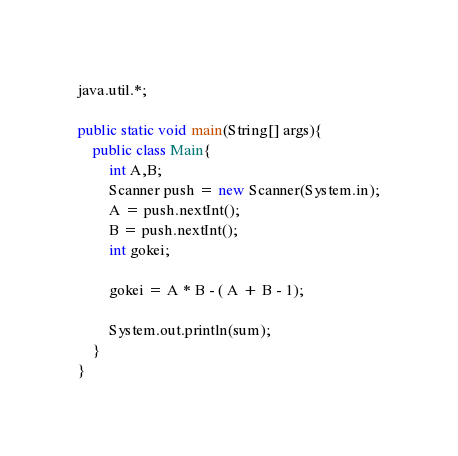<code> <loc_0><loc_0><loc_500><loc_500><_Java_>java.util.*;

public static void main(String[] args){
	public class Main{
  		int A,B;
  		Scanner push = new Scanner(System.in);
      	A = push.nextInt();
       	B = push.nextInt();
      	int gokei;
      
      	gokei = A * B - ( A + B - 1);
      	
      	System.out.println(sum);
    }
}</code> 